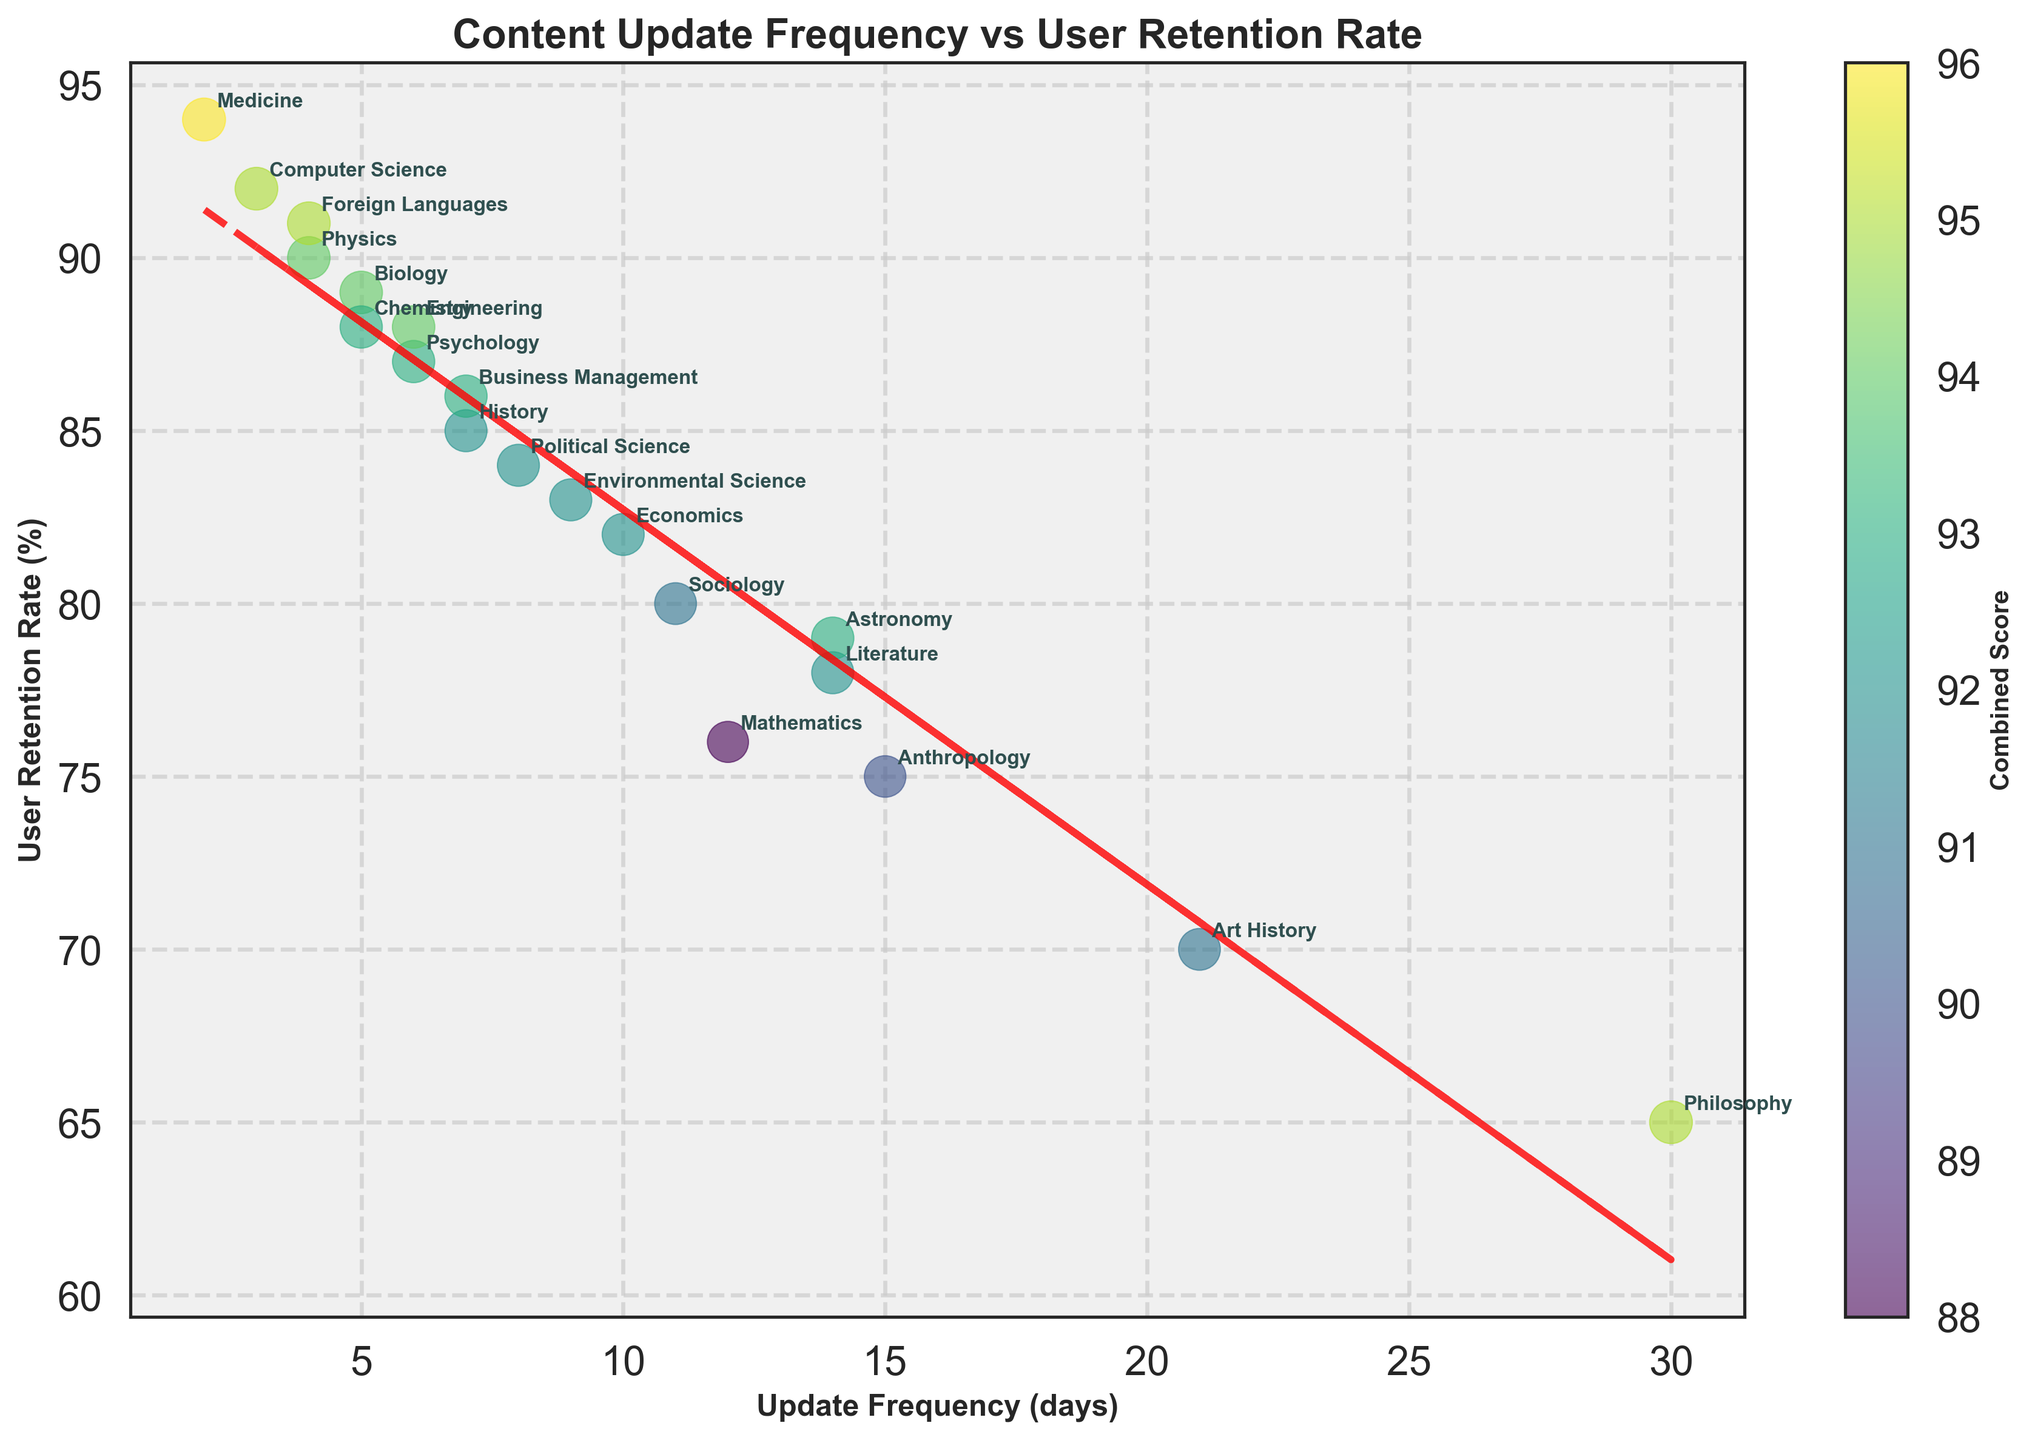What's the title of the plot? The title is usually written at the top of the figure in larger font size. Here, it's located at the top center of the plot in bold font.
Answer: Content Update Frequency vs User Retention Rate How many subject areas are presented in the plot? The number of subject areas can be determined by counting the different data points, each labeled with a subject name on the plot. By counting them, we see there are 19 points.
Answer: 19 Which subject has the highest user retention rate and what is that rate? Look for the data point on the y-axis that is the highest and check its label. Here, Medicine has the highest retention rate at 94%.
Answer: Medicine, 94% What is the update frequency in days for Computer Science? Identify the data point labeled "Computer Science" and read its corresponding x-axis value. Here, it’s 3 days.
Answer: 3 days Which subject has the lowest retention rate and what is that rate? Look for the data point on the y-axis that is the lowest and check its label. Here, Philosophy has the lowest retention rate at 65%.
Answer: Philosophy, 65% Which subject updates its content most frequently and how does it compare with its retention rate? Find the subject with the smallest x-axis value. Medicine updates every 2 days. We then check its y-axis value for the retention rate, which is 94%.
Answer: Medicine updates most frequently with a retention rate of 94% What is the combined score of Foreign Languages and how is it represented in the plot? The combined score is represented by the color and size of the point, calculated by adding the x and y-axis values. For Foreign Languages, it’s (4 + 91) = 95. This is inferred from the colorbar indicating combined scores.
Answer: 95 Is there a trend between update frequency and user retention rate shown in the plot? Identify the presence of a trendline. A red dashed line indicates a trend, suggesting a trend between more frequent updates and higher retention. The slope and direction of the line help determine the nature of the relationship.
Answer: Yes, there is a trend suggesting more frequent updates correlate with higher retention rates Which subjects fall between 5 and 10 days of update frequency and what are their retention rates? Identify data points between these x-axis values and note their labels and y-axis values. Sociology (80%), Psychology (87%), Political Science (84%), Environmental Science (83%), Business Management (86%), and Economics (82%) fall within this range.
Answer: Sociology (80%), Psychology (87%), Political Science (84%), Environmental Science (83%), Business Management (86%), Economics (82%) How do the retention rates of Art History and Philosophy compare when their update frequencies are relatively low? Identify the points for Art History and Philosophy on the plot. Art History updates every 21 days with a 70% retention rate; Philosophy updates every 30 days with a 65% retention rate. Comparatively, Art History has a slightly higher retention rate.
Answer: Art History has a higher retention rate (70%) compared to Philosophy (65%) 